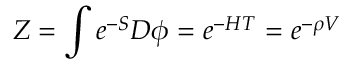<formula> <loc_0><loc_0><loc_500><loc_500>Z = \int e ^ { - S } D \phi = e ^ { - H T } = e ^ { - \rho V }</formula> 